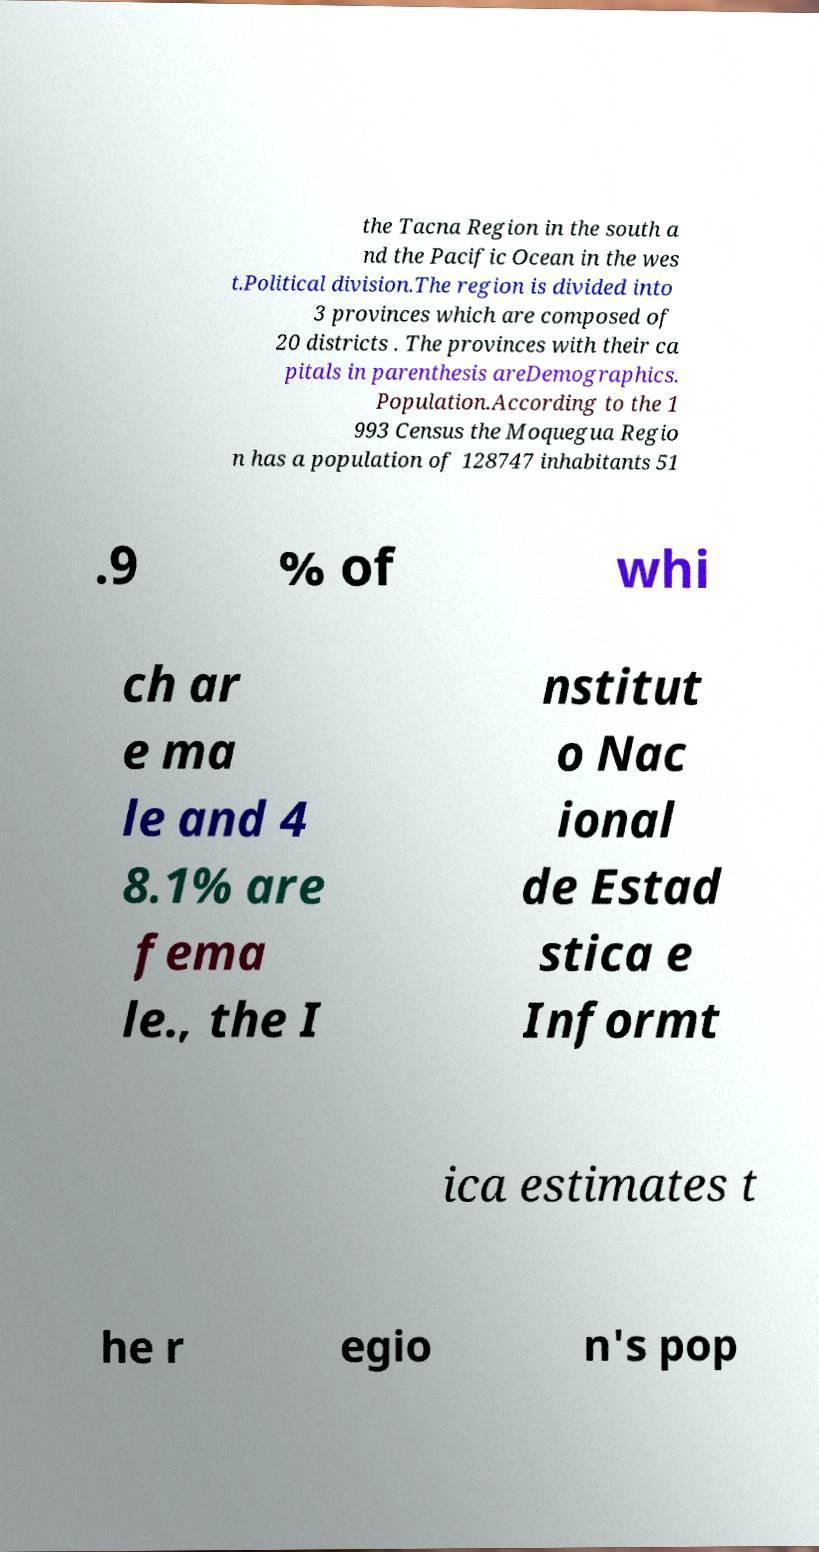Please read and relay the text visible in this image. What does it say? the Tacna Region in the south a nd the Pacific Ocean in the wes t.Political division.The region is divided into 3 provinces which are composed of 20 districts . The provinces with their ca pitals in parenthesis areDemographics. Population.According to the 1 993 Census the Moquegua Regio n has a population of 128747 inhabitants 51 .9 % of whi ch ar e ma le and 4 8.1% are fema le., the I nstitut o Nac ional de Estad stica e Informt ica estimates t he r egio n's pop 